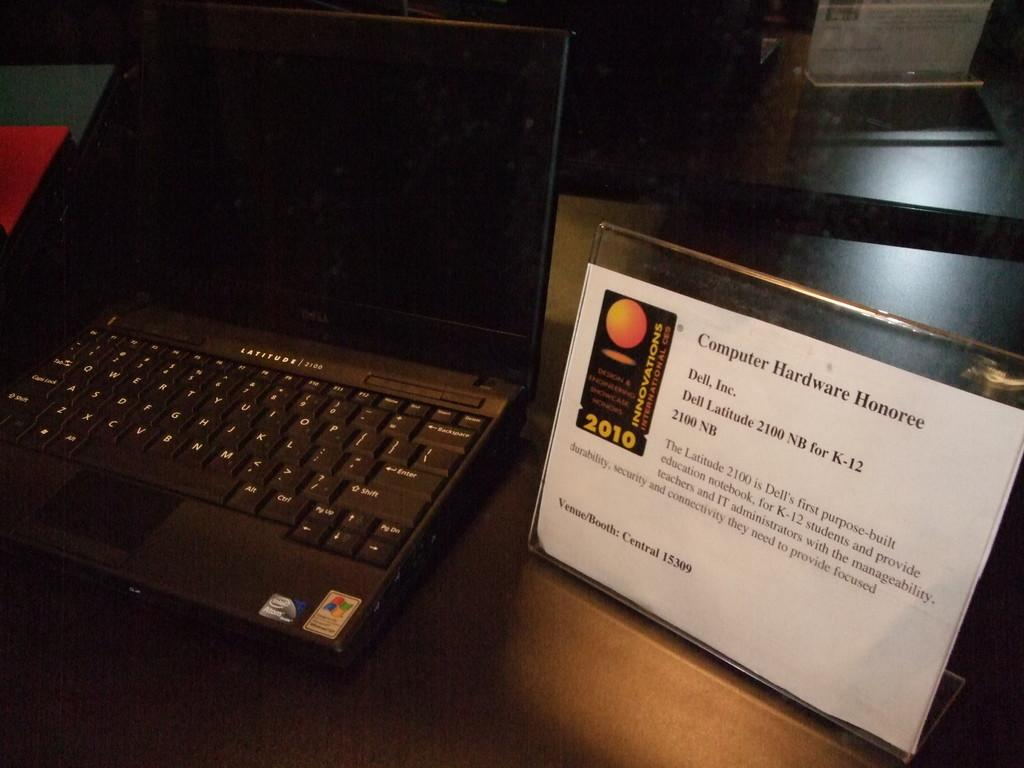<image>
Give a short and clear explanation of the subsequent image. a paper next to a laptop that says 'computer hardware honoree' on it 